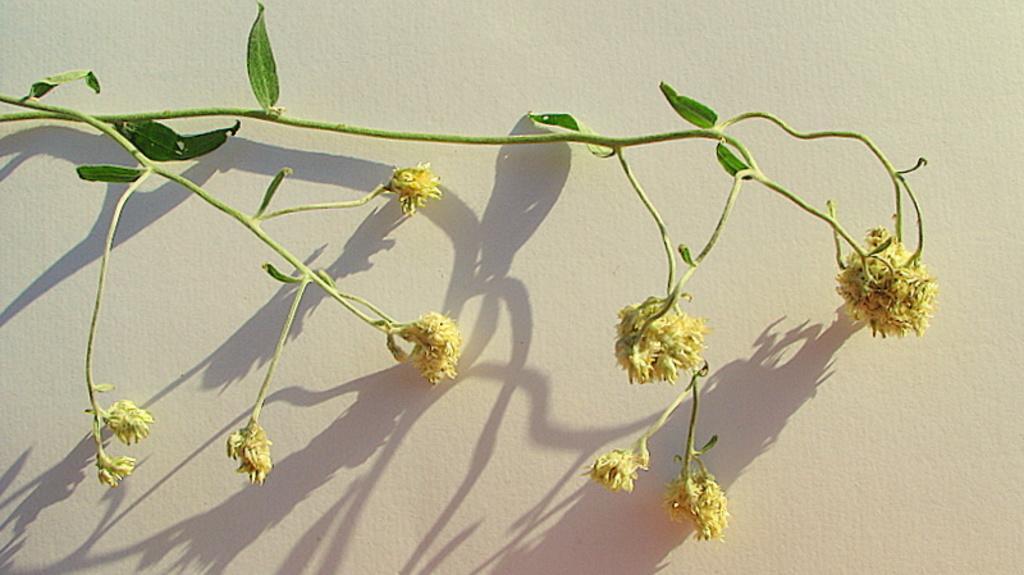How would you summarize this image in a sentence or two? In the center of the picture there are flowers and leaves and stems of a plant, behind the plant there is a wall painted white. 